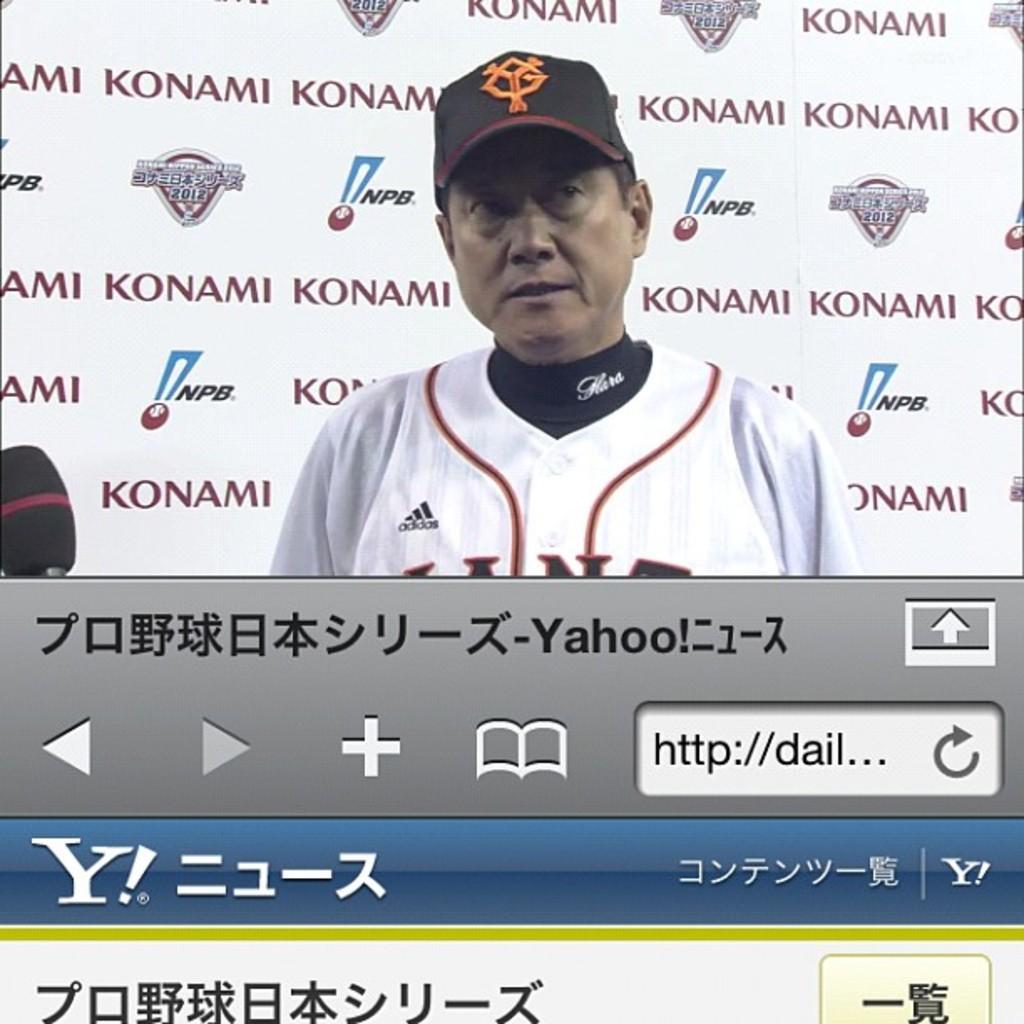Who is a sponsor for this press conference?
Your response must be concise. Konami. What team does this person support?
Provide a succinct answer. Unanswerable. 